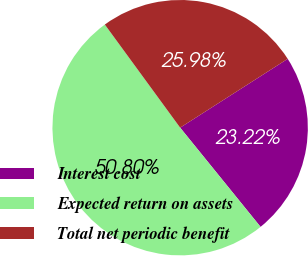<chart> <loc_0><loc_0><loc_500><loc_500><pie_chart><fcel>Interest cost<fcel>Expected return on assets<fcel>Total net periodic benefit<nl><fcel>23.22%<fcel>50.8%<fcel>25.98%<nl></chart> 